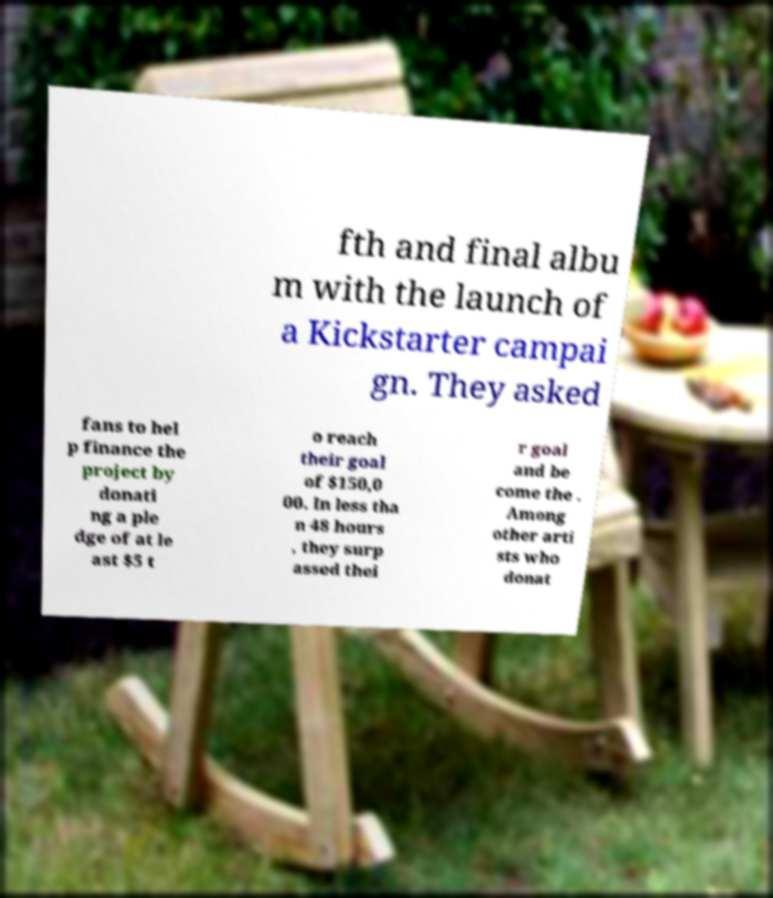What messages or text are displayed in this image? I need them in a readable, typed format. fth and final albu m with the launch of a Kickstarter campai gn. They asked fans to hel p finance the project by donati ng a ple dge of at le ast $5 t o reach their goal of $150,0 00. In less tha n 48 hours , they surp assed thei r goal and be come the . Among other arti sts who donat 